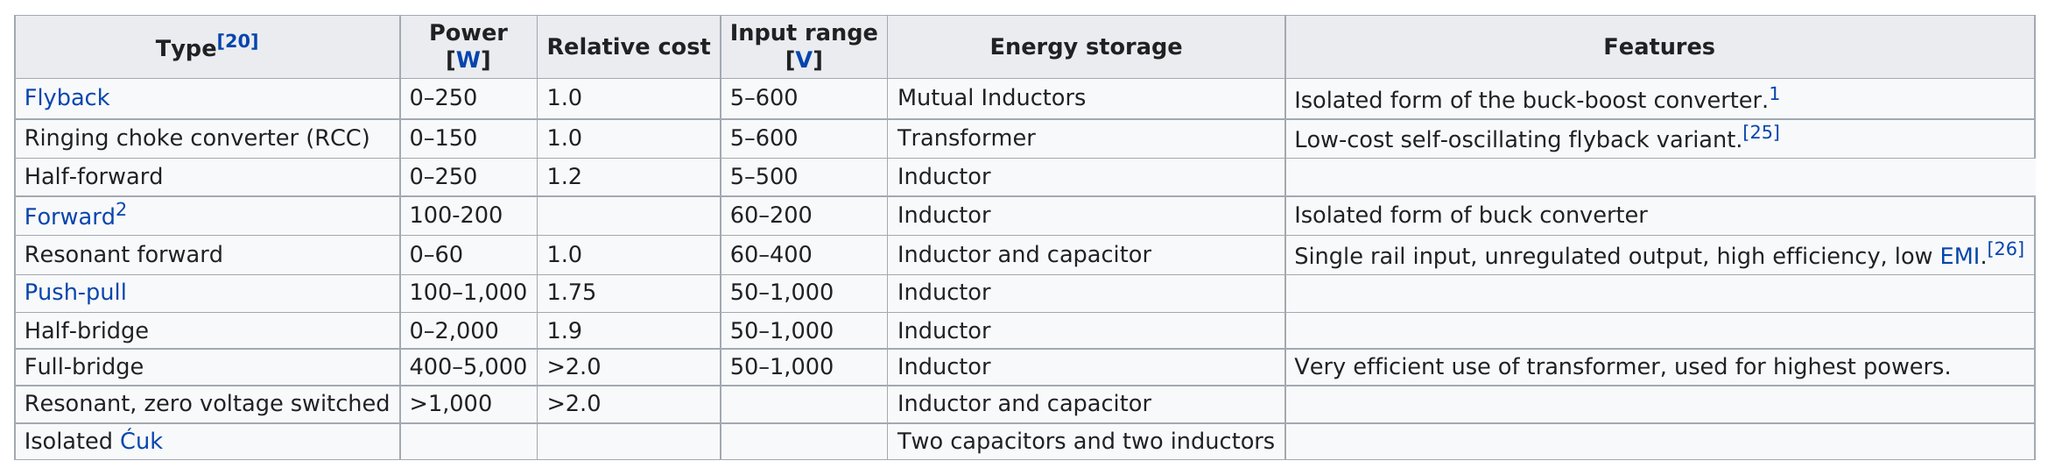Highlight a few significant elements in this photo. The total number of types listed is 10. Full-bridge converters are the most powerful and versatile type of DC-DC converter, with a wide input range that makes them suitable for a variety of applications. The energy storage of the half-bridge converter is not a transformer, but rather an inductor. The maximum voltage that the flyback converter can handle is 600 volts. What is the next highest relative cost to 1.75? It is 1.9. 